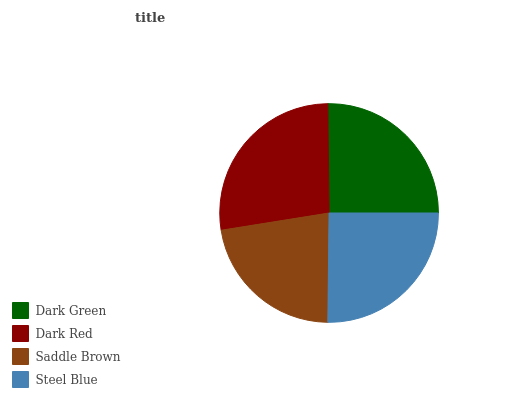Is Saddle Brown the minimum?
Answer yes or no. Yes. Is Dark Red the maximum?
Answer yes or no. Yes. Is Dark Red the minimum?
Answer yes or no. No. Is Saddle Brown the maximum?
Answer yes or no. No. Is Dark Red greater than Saddle Brown?
Answer yes or no. Yes. Is Saddle Brown less than Dark Red?
Answer yes or no. Yes. Is Saddle Brown greater than Dark Red?
Answer yes or no. No. Is Dark Red less than Saddle Brown?
Answer yes or no. No. Is Dark Green the high median?
Answer yes or no. Yes. Is Steel Blue the low median?
Answer yes or no. Yes. Is Saddle Brown the high median?
Answer yes or no. No. Is Saddle Brown the low median?
Answer yes or no. No. 